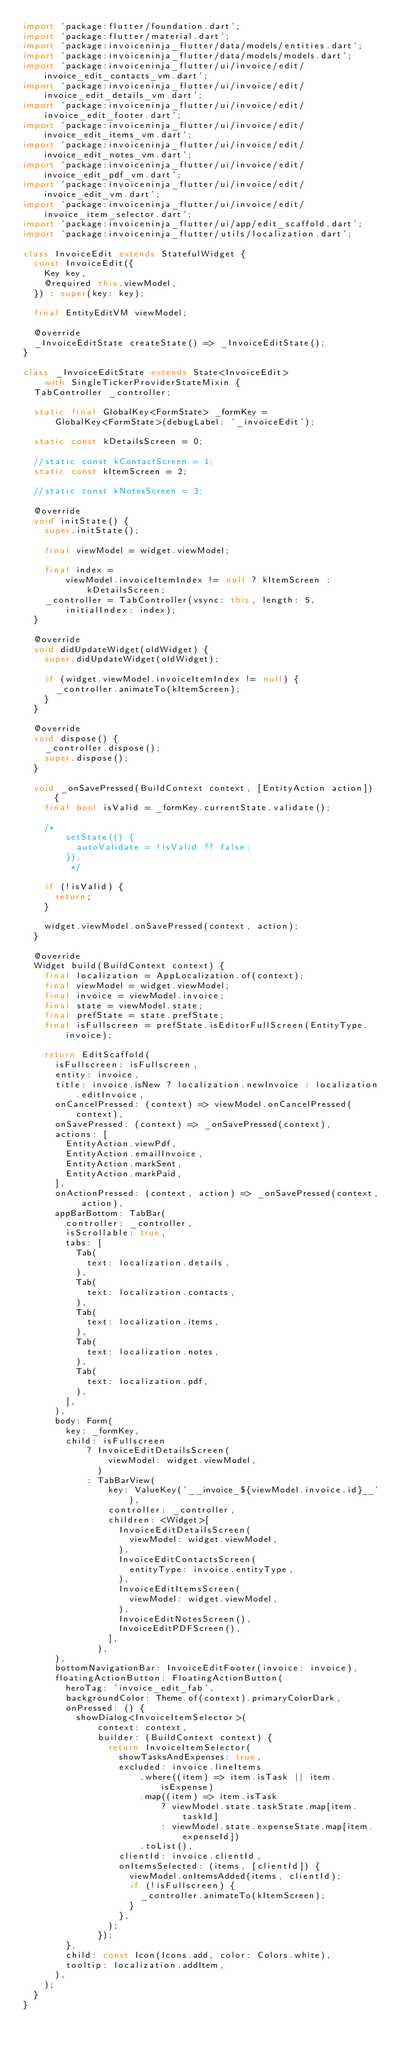<code> <loc_0><loc_0><loc_500><loc_500><_Dart_>import 'package:flutter/foundation.dart';
import 'package:flutter/material.dart';
import 'package:invoiceninja_flutter/data/models/entities.dart';
import 'package:invoiceninja_flutter/data/models/models.dart';
import 'package:invoiceninja_flutter/ui/invoice/edit/invoice_edit_contacts_vm.dart';
import 'package:invoiceninja_flutter/ui/invoice/edit/invoice_edit_details_vm.dart';
import 'package:invoiceninja_flutter/ui/invoice/edit/invoice_edit_footer.dart';
import 'package:invoiceninja_flutter/ui/invoice/edit/invoice_edit_items_vm.dart';
import 'package:invoiceninja_flutter/ui/invoice/edit/invoice_edit_notes_vm.dart';
import 'package:invoiceninja_flutter/ui/invoice/edit/invoice_edit_pdf_vm.dart';
import 'package:invoiceninja_flutter/ui/invoice/edit/invoice_edit_vm.dart';
import 'package:invoiceninja_flutter/ui/invoice/edit/invoice_item_selector.dart';
import 'package:invoiceninja_flutter/ui/app/edit_scaffold.dart';
import 'package:invoiceninja_flutter/utils/localization.dart';

class InvoiceEdit extends StatefulWidget {
  const InvoiceEdit({
    Key key,
    @required this.viewModel,
  }) : super(key: key);

  final EntityEditVM viewModel;

  @override
  _InvoiceEditState createState() => _InvoiceEditState();
}

class _InvoiceEditState extends State<InvoiceEdit>
    with SingleTickerProviderStateMixin {
  TabController _controller;

  static final GlobalKey<FormState> _formKey =
      GlobalKey<FormState>(debugLabel: '_invoiceEdit');

  static const kDetailsScreen = 0;

  //static const kContactScreen = 1;
  static const kItemScreen = 2;

  //static const kNotesScreen = 3;

  @override
  void initState() {
    super.initState();

    final viewModel = widget.viewModel;

    final index =
        viewModel.invoiceItemIndex != null ? kItemScreen : kDetailsScreen;
    _controller = TabController(vsync: this, length: 5, initialIndex: index);
  }

  @override
  void didUpdateWidget(oldWidget) {
    super.didUpdateWidget(oldWidget);

    if (widget.viewModel.invoiceItemIndex != null) {
      _controller.animateTo(kItemScreen);
    }
  }

  @override
  void dispose() {
    _controller.dispose();
    super.dispose();
  }

  void _onSavePressed(BuildContext context, [EntityAction action]) {
    final bool isValid = _formKey.currentState.validate();

    /*
        setState(() {
          autoValidate = !isValid ?? false;
        });
         */

    if (!isValid) {
      return;
    }

    widget.viewModel.onSavePressed(context, action);
  }

  @override
  Widget build(BuildContext context) {
    final localization = AppLocalization.of(context);
    final viewModel = widget.viewModel;
    final invoice = viewModel.invoice;
    final state = viewModel.state;
    final prefState = state.prefState;
    final isFullscreen = prefState.isEditorFullScreen(EntityType.invoice);

    return EditScaffold(
      isFullscreen: isFullscreen,
      entity: invoice,
      title: invoice.isNew ? localization.newInvoice : localization.editInvoice,
      onCancelPressed: (context) => viewModel.onCancelPressed(context),
      onSavePressed: (context) => _onSavePressed(context),
      actions: [
        EntityAction.viewPdf,
        EntityAction.emailInvoice,
        EntityAction.markSent,
        EntityAction.markPaid,
      ],
      onActionPressed: (context, action) => _onSavePressed(context, action),
      appBarBottom: TabBar(
        controller: _controller,
        isScrollable: true,
        tabs: [
          Tab(
            text: localization.details,
          ),
          Tab(
            text: localization.contacts,
          ),
          Tab(
            text: localization.items,
          ),
          Tab(
            text: localization.notes,
          ),
          Tab(
            text: localization.pdf,
          ),
        ],
      ),
      body: Form(
        key: _formKey,
        child: isFullscreen
            ? InvoiceEditDetailsScreen(
                viewModel: widget.viewModel,
              )
            : TabBarView(
                key: ValueKey('__invoice_${viewModel.invoice.id}__'),
                controller: _controller,
                children: <Widget>[
                  InvoiceEditDetailsScreen(
                    viewModel: widget.viewModel,
                  ),
                  InvoiceEditContactsScreen(
                    entityType: invoice.entityType,
                  ),
                  InvoiceEditItemsScreen(
                    viewModel: widget.viewModel,
                  ),
                  InvoiceEditNotesScreen(),
                  InvoiceEditPDFScreen(),
                ],
              ),
      ),
      bottomNavigationBar: InvoiceEditFooter(invoice: invoice),
      floatingActionButton: FloatingActionButton(
        heroTag: 'invoice_edit_fab',
        backgroundColor: Theme.of(context).primaryColorDark,
        onPressed: () {
          showDialog<InvoiceItemSelector>(
              context: context,
              builder: (BuildContext context) {
                return InvoiceItemSelector(
                  showTasksAndExpenses: true,
                  excluded: invoice.lineItems
                      .where((item) => item.isTask || item.isExpense)
                      .map((item) => item.isTask
                          ? viewModel.state.taskState.map[item.taskId]
                          : viewModel.state.expenseState.map[item.expenseId])
                      .toList(),
                  clientId: invoice.clientId,
                  onItemsSelected: (items, [clientId]) {
                    viewModel.onItemsAdded(items, clientId);
                    if (!isFullscreen) {
                      _controller.animateTo(kItemScreen);
                    }
                  },
                );
              });
        },
        child: const Icon(Icons.add, color: Colors.white),
        tooltip: localization.addItem,
      ),
    );
  }
}
</code> 